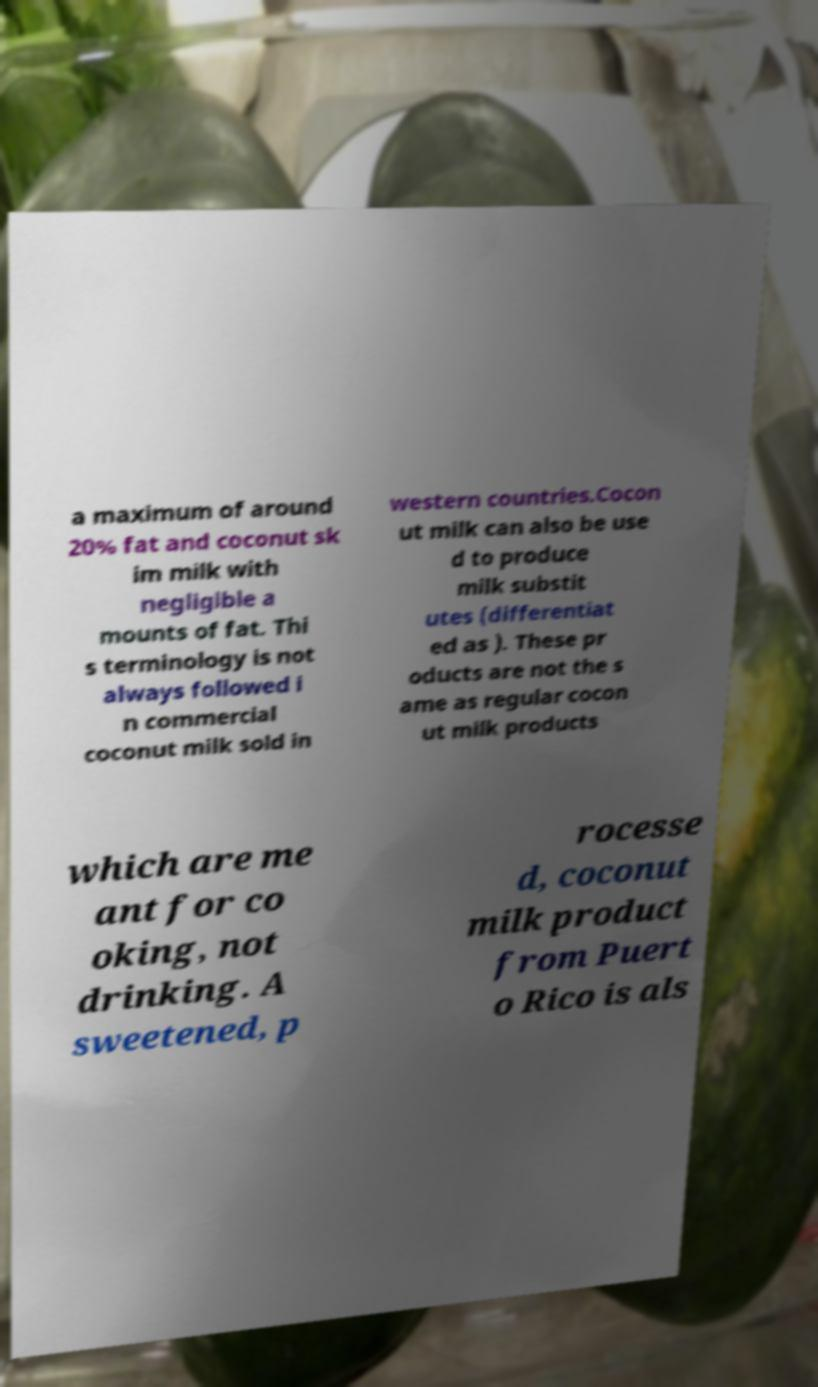There's text embedded in this image that I need extracted. Can you transcribe it verbatim? a maximum of around 20% fat and coconut sk im milk with negligible a mounts of fat. Thi s terminology is not always followed i n commercial coconut milk sold in western countries.Cocon ut milk can also be use d to produce milk substit utes (differentiat ed as ). These pr oducts are not the s ame as regular cocon ut milk products which are me ant for co oking, not drinking. A sweetened, p rocesse d, coconut milk product from Puert o Rico is als 